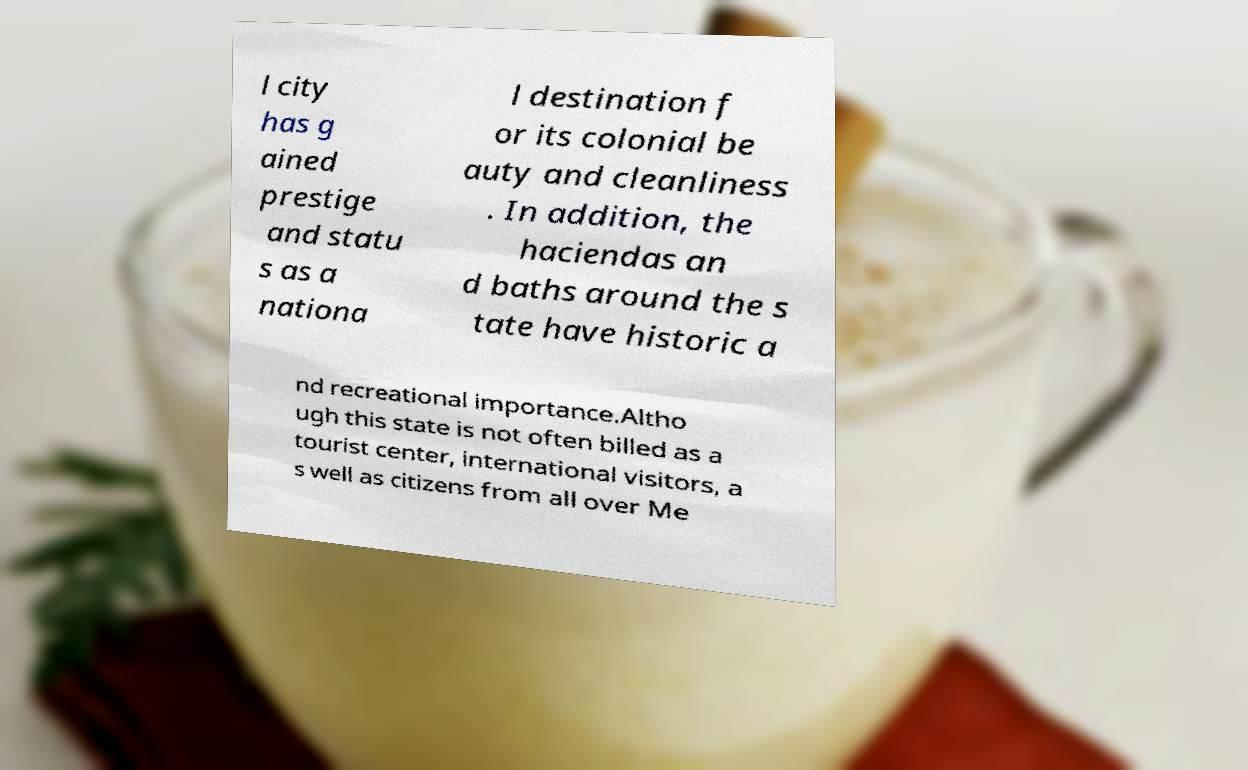Please identify and transcribe the text found in this image. l city has g ained prestige and statu s as a nationa l destination f or its colonial be auty and cleanliness . In addition, the haciendas an d baths around the s tate have historic a nd recreational importance.Altho ugh this state is not often billed as a tourist center, international visitors, a s well as citizens from all over Me 